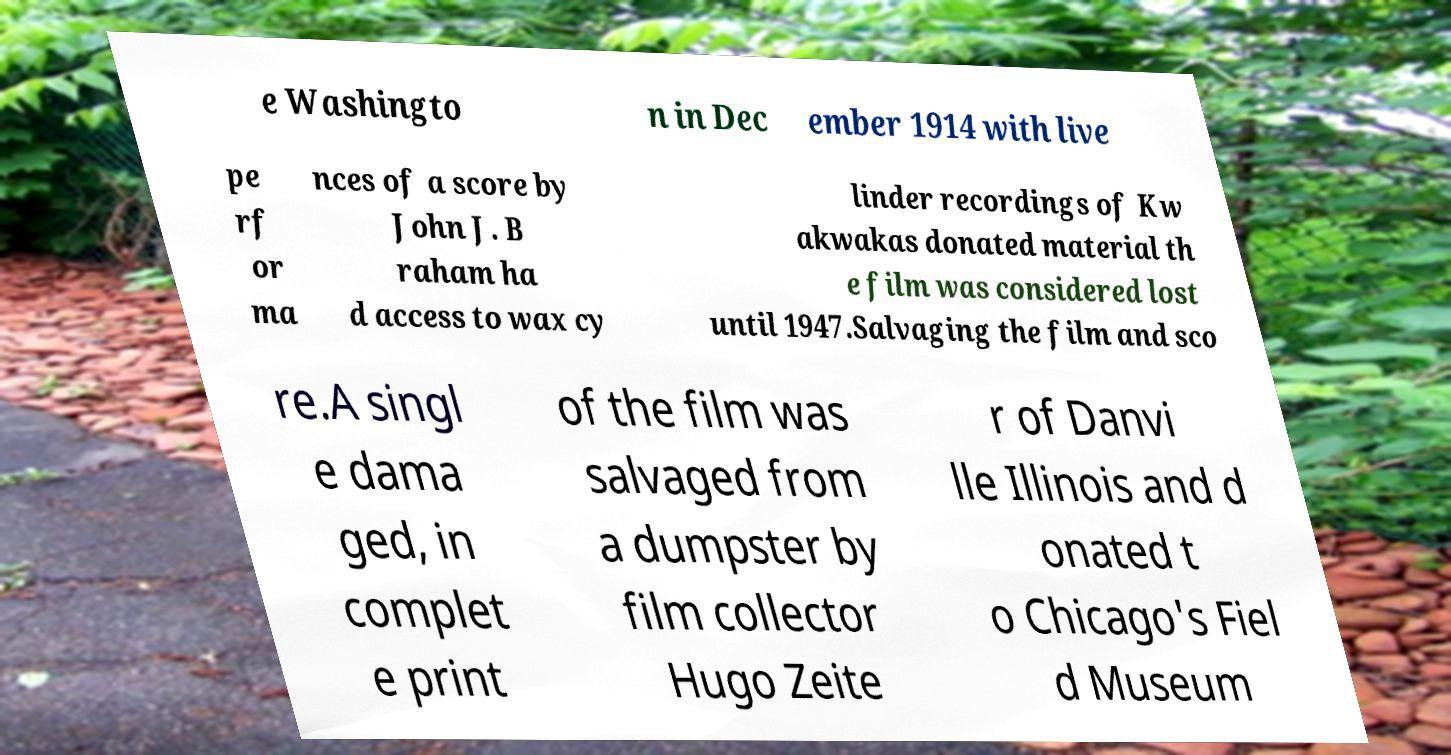Could you assist in decoding the text presented in this image and type it out clearly? e Washingto n in Dec ember 1914 with live pe rf or ma nces of a score by John J. B raham ha d access to wax cy linder recordings of Kw akwakas donated material th e film was considered lost until 1947.Salvaging the film and sco re.A singl e dama ged, in complet e print of the film was salvaged from a dumpster by film collector Hugo Zeite r of Danvi lle Illinois and d onated t o Chicago's Fiel d Museum 